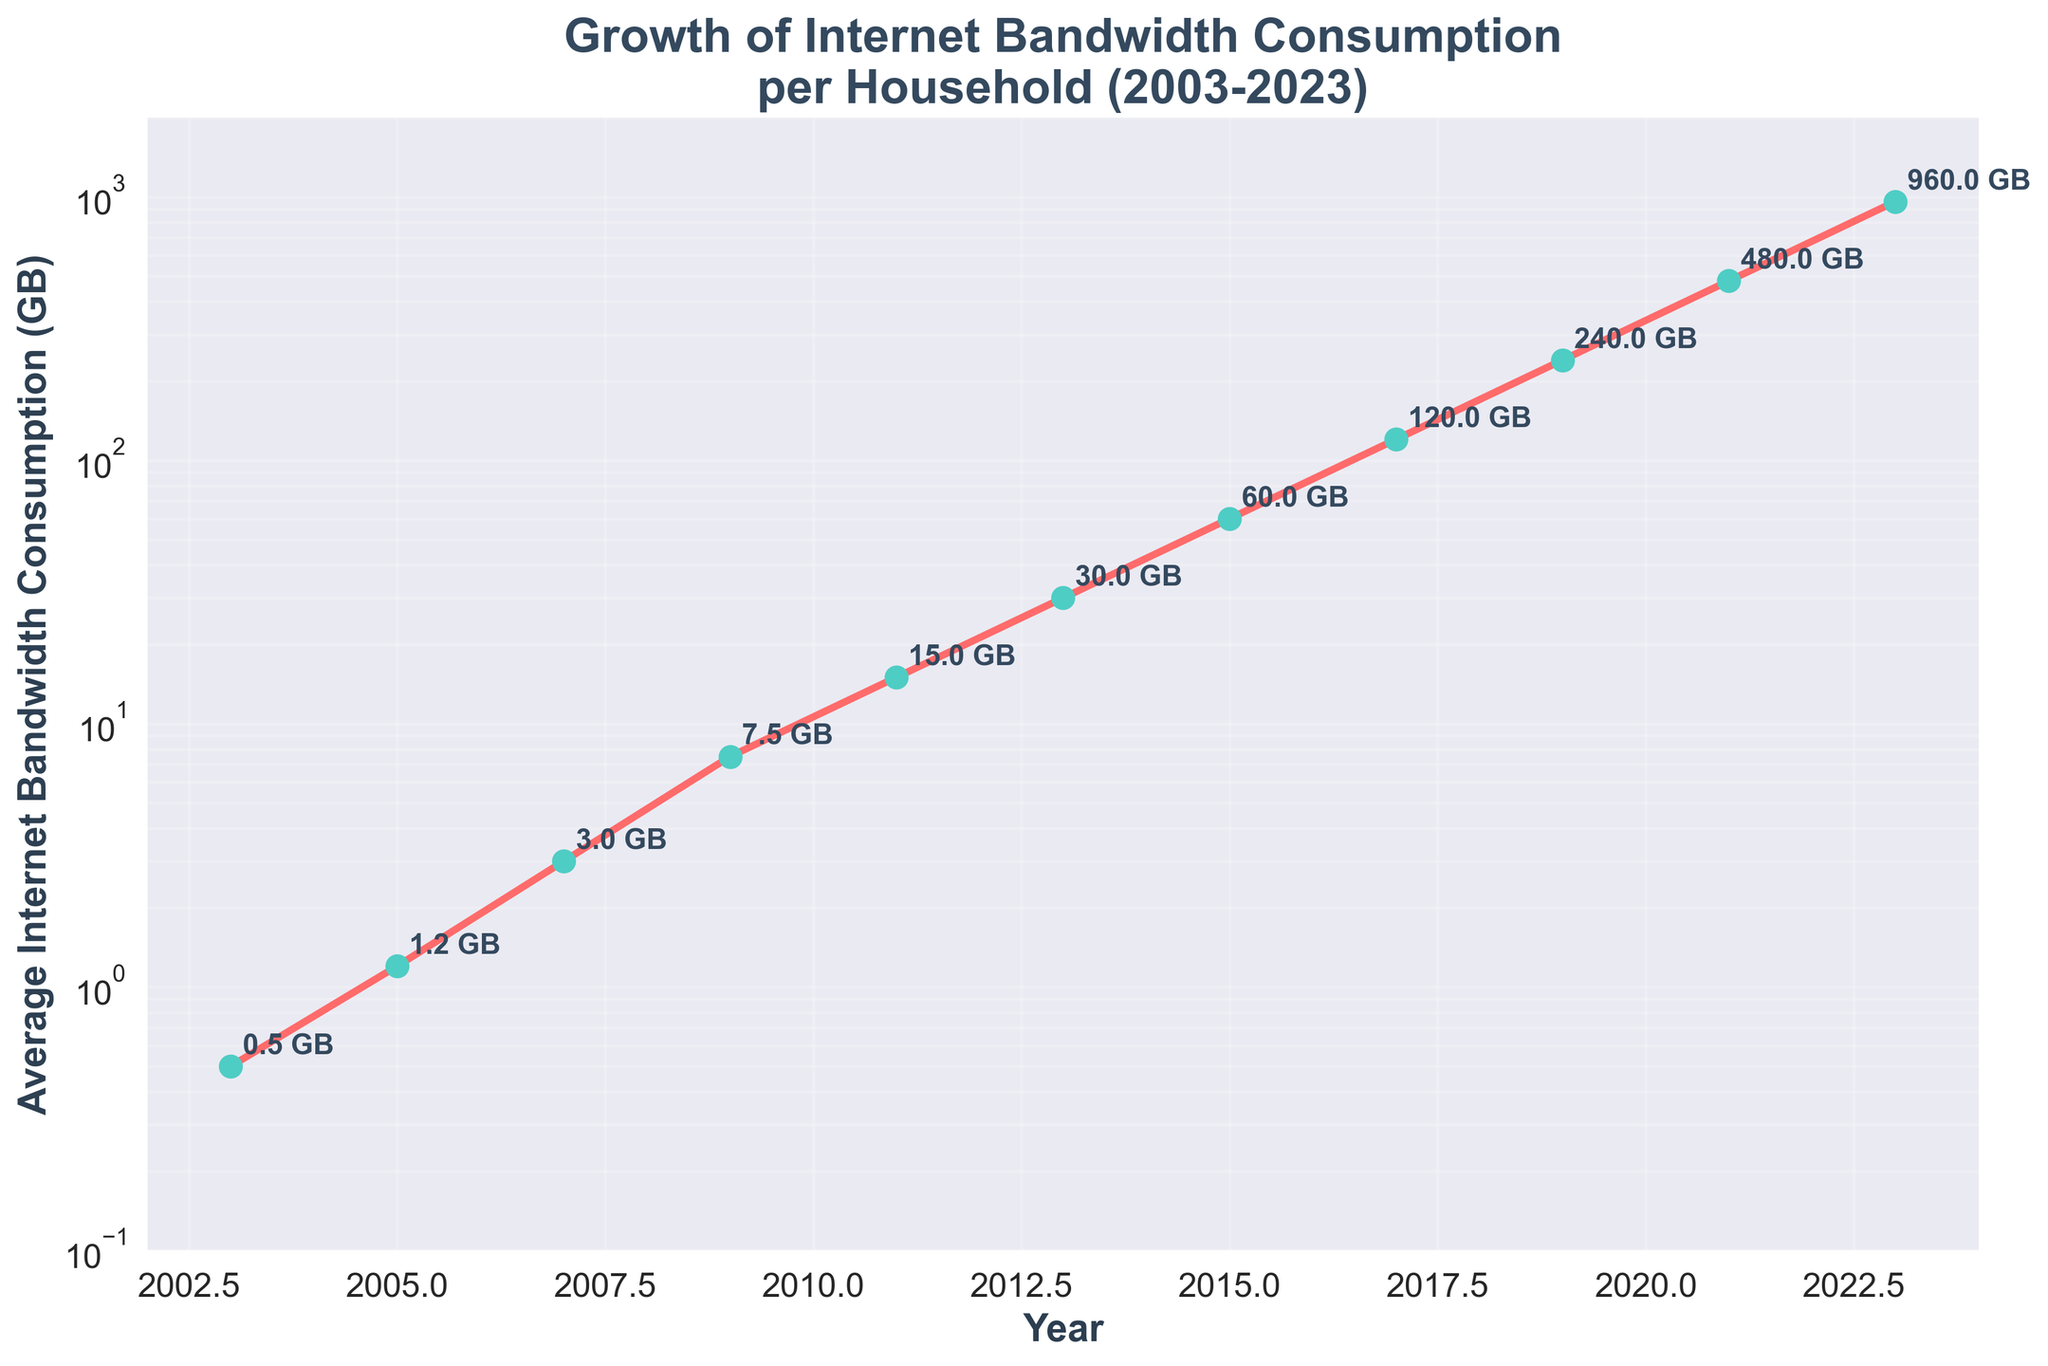What is the title of the figure? The title is usually found at the top of the figure, often in larger or bolded text. The title helps to understand the main topic represented in the plot.
Answer: Growth of Internet Bandwidth Consumption per Household (2003-2023) How many data points are plotted in the figure? The data points are marked with circles on the plot. Counting these circles gives you the number of data points. There is one data point for each year listed on the x-axis.
Answer: 11 What was the average internet bandwidth consumption in 2009? Find the data point corresponding to the year 2009 on the x-axis and read its value from the y-axis. The value might also be annotated next to the data point.
Answer: 7.5 GB By what factor did internet bandwidth consumption increase from 2007 to 2021? To find the factor of increase, divide the value in 2021 by the value in 2007. Look at the respective data points and read their values. 2021: 480 GB, 2007: 3 GB. Calculate 480 / 3.
Answer: 160 Which year had the smallest average internet bandwidth consumption? Find the smallest value on the y-axis, and then check its corresponding year on the x-axis.
Answer: 2003 What is the difference in bandwidth consumption between the years 2011 and 2013? Subtract the value of 2011 from the value of 2013. 2013: 30 GB, 2011: 15 GB. Calculate 30 - 15.
Answer: 15 GB In which period did the internet bandwidth consumption double? Examine the y-axis values for each year and find a period where the value approximately doubles from one year to the next. One example is from 2009 (7.5 GB) to 2011 (15 GB).
Answer: 2009 to 2011 Between which two consecutive years was the highest growth rate in bandwidth consumption observed? Calculate the growth rate by finding the difference in consumption between consecutive years and identifying the largest difference. Consider 2019: 240 GB and 2021: 480 GB. Calculate 480 - 240.
Answer: 2019 to 2021 What is the average bandwidth consumption over the entire period? Add up all the values and divide by the number of years (11). Sum is 0.5 + 1.2 + 3.0 + 7.5 + 15.0 + 30.0 + 60.0 + 120.0 + 240.0 + 480.0 + 960.0 = 1917.2. Divide 1917.2 by 11.
Answer: 174.3 GB How many times did the bandwidth consumption increase from 2003 to 2023? Divide the value in 2023 by the value in 2003. 2023: 960 GB, 2003: 0.5 GB. Calculate 960 / 0.5.
Answer: 1920 